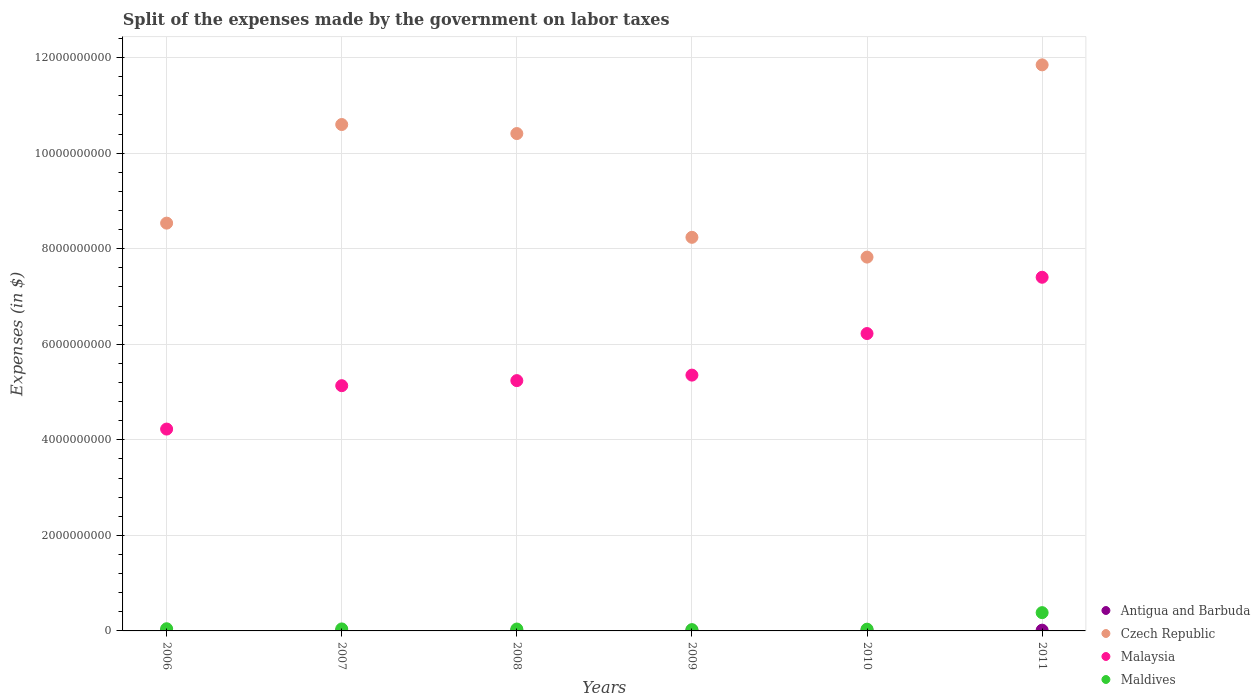How many different coloured dotlines are there?
Make the answer very short. 4. Is the number of dotlines equal to the number of legend labels?
Provide a succinct answer. Yes. What is the expenses made by the government on labor taxes in Czech Republic in 2009?
Give a very brief answer. 8.24e+09. Across all years, what is the maximum expenses made by the government on labor taxes in Antigua and Barbuda?
Your answer should be compact. 1.77e+07. Across all years, what is the minimum expenses made by the government on labor taxes in Antigua and Barbuda?
Your response must be concise. 8.90e+06. In which year was the expenses made by the government on labor taxes in Malaysia minimum?
Keep it short and to the point. 2006. What is the total expenses made by the government on labor taxes in Czech Republic in the graph?
Provide a succinct answer. 5.75e+1. What is the difference between the expenses made by the government on labor taxes in Malaysia in 2006 and that in 2010?
Your response must be concise. -2.00e+09. What is the difference between the expenses made by the government on labor taxes in Malaysia in 2006 and the expenses made by the government on labor taxes in Czech Republic in 2011?
Your answer should be compact. -7.62e+09. What is the average expenses made by the government on labor taxes in Czech Republic per year?
Your answer should be very brief. 9.58e+09. In the year 2011, what is the difference between the expenses made by the government on labor taxes in Antigua and Barbuda and expenses made by the government on labor taxes in Czech Republic?
Give a very brief answer. -1.18e+1. In how many years, is the expenses made by the government on labor taxes in Antigua and Barbuda greater than 1600000000 $?
Provide a short and direct response. 0. What is the ratio of the expenses made by the government on labor taxes in Antigua and Barbuda in 2008 to that in 2009?
Provide a short and direct response. 0.95. What is the difference between the highest and the second highest expenses made by the government on labor taxes in Maldives?
Provide a succinct answer. 3.37e+08. What is the difference between the highest and the lowest expenses made by the government on labor taxes in Maldives?
Keep it short and to the point. 3.55e+08. Does the expenses made by the government on labor taxes in Malaysia monotonically increase over the years?
Your answer should be compact. Yes. Is the expenses made by the government on labor taxes in Maldives strictly greater than the expenses made by the government on labor taxes in Czech Republic over the years?
Your answer should be very brief. No. Is the expenses made by the government on labor taxes in Antigua and Barbuda strictly less than the expenses made by the government on labor taxes in Malaysia over the years?
Your response must be concise. Yes. How many years are there in the graph?
Provide a succinct answer. 6. How many legend labels are there?
Your answer should be compact. 4. How are the legend labels stacked?
Keep it short and to the point. Vertical. What is the title of the graph?
Give a very brief answer. Split of the expenses made by the government on labor taxes. What is the label or title of the Y-axis?
Your answer should be very brief. Expenses (in $). What is the Expenses (in $) of Antigua and Barbuda in 2006?
Keep it short and to the point. 1.13e+07. What is the Expenses (in $) in Czech Republic in 2006?
Your answer should be compact. 8.54e+09. What is the Expenses (in $) in Malaysia in 2006?
Provide a succinct answer. 4.23e+09. What is the Expenses (in $) of Maldives in 2006?
Give a very brief answer. 4.56e+07. What is the Expenses (in $) of Antigua and Barbuda in 2007?
Provide a succinct answer. 8.90e+06. What is the Expenses (in $) of Czech Republic in 2007?
Your answer should be compact. 1.06e+1. What is the Expenses (in $) in Malaysia in 2007?
Make the answer very short. 5.13e+09. What is the Expenses (in $) in Maldives in 2007?
Ensure brevity in your answer.  4.18e+07. What is the Expenses (in $) of Antigua and Barbuda in 2008?
Keep it short and to the point. 1.41e+07. What is the Expenses (in $) in Czech Republic in 2008?
Ensure brevity in your answer.  1.04e+1. What is the Expenses (in $) in Malaysia in 2008?
Provide a succinct answer. 5.24e+09. What is the Expenses (in $) in Maldives in 2008?
Your response must be concise. 3.97e+07. What is the Expenses (in $) of Antigua and Barbuda in 2009?
Provide a short and direct response. 1.49e+07. What is the Expenses (in $) of Czech Republic in 2009?
Your answer should be compact. 8.24e+09. What is the Expenses (in $) in Malaysia in 2009?
Keep it short and to the point. 5.35e+09. What is the Expenses (in $) in Maldives in 2009?
Ensure brevity in your answer.  2.71e+07. What is the Expenses (in $) in Antigua and Barbuda in 2010?
Your answer should be compact. 1.77e+07. What is the Expenses (in $) in Czech Republic in 2010?
Your answer should be compact. 7.82e+09. What is the Expenses (in $) in Malaysia in 2010?
Provide a succinct answer. 6.22e+09. What is the Expenses (in $) in Maldives in 2010?
Offer a very short reply. 3.69e+07. What is the Expenses (in $) of Antigua and Barbuda in 2011?
Provide a succinct answer. 1.60e+07. What is the Expenses (in $) in Czech Republic in 2011?
Make the answer very short. 1.18e+1. What is the Expenses (in $) in Malaysia in 2011?
Make the answer very short. 7.40e+09. What is the Expenses (in $) of Maldives in 2011?
Offer a terse response. 3.83e+08. Across all years, what is the maximum Expenses (in $) in Antigua and Barbuda?
Ensure brevity in your answer.  1.77e+07. Across all years, what is the maximum Expenses (in $) of Czech Republic?
Provide a succinct answer. 1.18e+1. Across all years, what is the maximum Expenses (in $) in Malaysia?
Your response must be concise. 7.40e+09. Across all years, what is the maximum Expenses (in $) of Maldives?
Offer a very short reply. 3.83e+08. Across all years, what is the minimum Expenses (in $) in Antigua and Barbuda?
Offer a very short reply. 8.90e+06. Across all years, what is the minimum Expenses (in $) in Czech Republic?
Give a very brief answer. 7.82e+09. Across all years, what is the minimum Expenses (in $) in Malaysia?
Offer a terse response. 4.23e+09. Across all years, what is the minimum Expenses (in $) in Maldives?
Your answer should be compact. 2.71e+07. What is the total Expenses (in $) in Antigua and Barbuda in the graph?
Keep it short and to the point. 8.29e+07. What is the total Expenses (in $) in Czech Republic in the graph?
Your answer should be compact. 5.75e+1. What is the total Expenses (in $) in Malaysia in the graph?
Your answer should be compact. 3.36e+1. What is the total Expenses (in $) in Maldives in the graph?
Offer a terse response. 5.74e+08. What is the difference between the Expenses (in $) in Antigua and Barbuda in 2006 and that in 2007?
Your answer should be very brief. 2.40e+06. What is the difference between the Expenses (in $) in Czech Republic in 2006 and that in 2007?
Offer a very short reply. -2.06e+09. What is the difference between the Expenses (in $) of Malaysia in 2006 and that in 2007?
Provide a succinct answer. -9.08e+08. What is the difference between the Expenses (in $) of Maldives in 2006 and that in 2007?
Your response must be concise. 3.80e+06. What is the difference between the Expenses (in $) of Antigua and Barbuda in 2006 and that in 2008?
Ensure brevity in your answer.  -2.80e+06. What is the difference between the Expenses (in $) in Czech Republic in 2006 and that in 2008?
Offer a terse response. -1.88e+09. What is the difference between the Expenses (in $) of Malaysia in 2006 and that in 2008?
Make the answer very short. -1.01e+09. What is the difference between the Expenses (in $) of Maldives in 2006 and that in 2008?
Keep it short and to the point. 5.90e+06. What is the difference between the Expenses (in $) in Antigua and Barbuda in 2006 and that in 2009?
Give a very brief answer. -3.60e+06. What is the difference between the Expenses (in $) in Czech Republic in 2006 and that in 2009?
Offer a terse response. 2.97e+08. What is the difference between the Expenses (in $) of Malaysia in 2006 and that in 2009?
Provide a succinct answer. -1.13e+09. What is the difference between the Expenses (in $) of Maldives in 2006 and that in 2009?
Your response must be concise. 1.85e+07. What is the difference between the Expenses (in $) in Antigua and Barbuda in 2006 and that in 2010?
Provide a succinct answer. -6.40e+06. What is the difference between the Expenses (in $) in Czech Republic in 2006 and that in 2010?
Your answer should be compact. 7.11e+08. What is the difference between the Expenses (in $) of Malaysia in 2006 and that in 2010?
Offer a very short reply. -2.00e+09. What is the difference between the Expenses (in $) of Maldives in 2006 and that in 2010?
Provide a short and direct response. 8.70e+06. What is the difference between the Expenses (in $) in Antigua and Barbuda in 2006 and that in 2011?
Ensure brevity in your answer.  -4.70e+06. What is the difference between the Expenses (in $) of Czech Republic in 2006 and that in 2011?
Offer a very short reply. -3.31e+09. What is the difference between the Expenses (in $) of Malaysia in 2006 and that in 2011?
Keep it short and to the point. -3.18e+09. What is the difference between the Expenses (in $) in Maldives in 2006 and that in 2011?
Provide a succinct answer. -3.37e+08. What is the difference between the Expenses (in $) in Antigua and Barbuda in 2007 and that in 2008?
Offer a very short reply. -5.20e+06. What is the difference between the Expenses (in $) of Czech Republic in 2007 and that in 2008?
Keep it short and to the point. 1.89e+08. What is the difference between the Expenses (in $) of Malaysia in 2007 and that in 2008?
Ensure brevity in your answer.  -1.06e+08. What is the difference between the Expenses (in $) in Maldives in 2007 and that in 2008?
Offer a very short reply. 2.10e+06. What is the difference between the Expenses (in $) in Antigua and Barbuda in 2007 and that in 2009?
Give a very brief answer. -6.00e+06. What is the difference between the Expenses (in $) in Czech Republic in 2007 and that in 2009?
Keep it short and to the point. 2.36e+09. What is the difference between the Expenses (in $) of Malaysia in 2007 and that in 2009?
Offer a terse response. -2.21e+08. What is the difference between the Expenses (in $) in Maldives in 2007 and that in 2009?
Provide a short and direct response. 1.47e+07. What is the difference between the Expenses (in $) of Antigua and Barbuda in 2007 and that in 2010?
Offer a very short reply. -8.80e+06. What is the difference between the Expenses (in $) of Czech Republic in 2007 and that in 2010?
Offer a very short reply. 2.78e+09. What is the difference between the Expenses (in $) in Malaysia in 2007 and that in 2010?
Your response must be concise. -1.09e+09. What is the difference between the Expenses (in $) in Maldives in 2007 and that in 2010?
Offer a terse response. 4.90e+06. What is the difference between the Expenses (in $) in Antigua and Barbuda in 2007 and that in 2011?
Keep it short and to the point. -7.10e+06. What is the difference between the Expenses (in $) in Czech Republic in 2007 and that in 2011?
Ensure brevity in your answer.  -1.25e+09. What is the difference between the Expenses (in $) of Malaysia in 2007 and that in 2011?
Provide a succinct answer. -2.27e+09. What is the difference between the Expenses (in $) in Maldives in 2007 and that in 2011?
Ensure brevity in your answer.  -3.41e+08. What is the difference between the Expenses (in $) of Antigua and Barbuda in 2008 and that in 2009?
Make the answer very short. -8.00e+05. What is the difference between the Expenses (in $) in Czech Republic in 2008 and that in 2009?
Your response must be concise. 2.17e+09. What is the difference between the Expenses (in $) in Malaysia in 2008 and that in 2009?
Give a very brief answer. -1.15e+08. What is the difference between the Expenses (in $) of Maldives in 2008 and that in 2009?
Your response must be concise. 1.26e+07. What is the difference between the Expenses (in $) in Antigua and Barbuda in 2008 and that in 2010?
Offer a very short reply. -3.60e+06. What is the difference between the Expenses (in $) in Czech Republic in 2008 and that in 2010?
Your answer should be compact. 2.59e+09. What is the difference between the Expenses (in $) of Malaysia in 2008 and that in 2010?
Give a very brief answer. -9.85e+08. What is the difference between the Expenses (in $) of Maldives in 2008 and that in 2010?
Provide a short and direct response. 2.80e+06. What is the difference between the Expenses (in $) of Antigua and Barbuda in 2008 and that in 2011?
Offer a very short reply. -1.90e+06. What is the difference between the Expenses (in $) in Czech Republic in 2008 and that in 2011?
Keep it short and to the point. -1.44e+09. What is the difference between the Expenses (in $) in Malaysia in 2008 and that in 2011?
Your response must be concise. -2.16e+09. What is the difference between the Expenses (in $) in Maldives in 2008 and that in 2011?
Provide a succinct answer. -3.43e+08. What is the difference between the Expenses (in $) of Antigua and Barbuda in 2009 and that in 2010?
Make the answer very short. -2.80e+06. What is the difference between the Expenses (in $) in Czech Republic in 2009 and that in 2010?
Provide a short and direct response. 4.14e+08. What is the difference between the Expenses (in $) of Malaysia in 2009 and that in 2010?
Ensure brevity in your answer.  -8.70e+08. What is the difference between the Expenses (in $) in Maldives in 2009 and that in 2010?
Give a very brief answer. -9.80e+06. What is the difference between the Expenses (in $) of Antigua and Barbuda in 2009 and that in 2011?
Make the answer very short. -1.10e+06. What is the difference between the Expenses (in $) of Czech Republic in 2009 and that in 2011?
Ensure brevity in your answer.  -3.61e+09. What is the difference between the Expenses (in $) in Malaysia in 2009 and that in 2011?
Your response must be concise. -2.05e+09. What is the difference between the Expenses (in $) in Maldives in 2009 and that in 2011?
Your answer should be compact. -3.55e+08. What is the difference between the Expenses (in $) of Antigua and Barbuda in 2010 and that in 2011?
Make the answer very short. 1.70e+06. What is the difference between the Expenses (in $) in Czech Republic in 2010 and that in 2011?
Offer a very short reply. -4.02e+09. What is the difference between the Expenses (in $) of Malaysia in 2010 and that in 2011?
Provide a short and direct response. -1.18e+09. What is the difference between the Expenses (in $) in Maldives in 2010 and that in 2011?
Keep it short and to the point. -3.46e+08. What is the difference between the Expenses (in $) of Antigua and Barbuda in 2006 and the Expenses (in $) of Czech Republic in 2007?
Offer a terse response. -1.06e+1. What is the difference between the Expenses (in $) in Antigua and Barbuda in 2006 and the Expenses (in $) in Malaysia in 2007?
Make the answer very short. -5.12e+09. What is the difference between the Expenses (in $) of Antigua and Barbuda in 2006 and the Expenses (in $) of Maldives in 2007?
Provide a short and direct response. -3.05e+07. What is the difference between the Expenses (in $) of Czech Republic in 2006 and the Expenses (in $) of Malaysia in 2007?
Provide a succinct answer. 3.40e+09. What is the difference between the Expenses (in $) in Czech Republic in 2006 and the Expenses (in $) in Maldives in 2007?
Give a very brief answer. 8.49e+09. What is the difference between the Expenses (in $) in Malaysia in 2006 and the Expenses (in $) in Maldives in 2007?
Your answer should be compact. 4.18e+09. What is the difference between the Expenses (in $) in Antigua and Barbuda in 2006 and the Expenses (in $) in Czech Republic in 2008?
Make the answer very short. -1.04e+1. What is the difference between the Expenses (in $) of Antigua and Barbuda in 2006 and the Expenses (in $) of Malaysia in 2008?
Offer a terse response. -5.23e+09. What is the difference between the Expenses (in $) in Antigua and Barbuda in 2006 and the Expenses (in $) in Maldives in 2008?
Keep it short and to the point. -2.84e+07. What is the difference between the Expenses (in $) of Czech Republic in 2006 and the Expenses (in $) of Malaysia in 2008?
Keep it short and to the point. 3.30e+09. What is the difference between the Expenses (in $) of Czech Republic in 2006 and the Expenses (in $) of Maldives in 2008?
Offer a terse response. 8.50e+09. What is the difference between the Expenses (in $) of Malaysia in 2006 and the Expenses (in $) of Maldives in 2008?
Ensure brevity in your answer.  4.19e+09. What is the difference between the Expenses (in $) in Antigua and Barbuda in 2006 and the Expenses (in $) in Czech Republic in 2009?
Offer a terse response. -8.23e+09. What is the difference between the Expenses (in $) of Antigua and Barbuda in 2006 and the Expenses (in $) of Malaysia in 2009?
Keep it short and to the point. -5.34e+09. What is the difference between the Expenses (in $) of Antigua and Barbuda in 2006 and the Expenses (in $) of Maldives in 2009?
Keep it short and to the point. -1.58e+07. What is the difference between the Expenses (in $) in Czech Republic in 2006 and the Expenses (in $) in Malaysia in 2009?
Make the answer very short. 3.18e+09. What is the difference between the Expenses (in $) in Czech Republic in 2006 and the Expenses (in $) in Maldives in 2009?
Your answer should be compact. 8.51e+09. What is the difference between the Expenses (in $) in Malaysia in 2006 and the Expenses (in $) in Maldives in 2009?
Your answer should be compact. 4.20e+09. What is the difference between the Expenses (in $) of Antigua and Barbuda in 2006 and the Expenses (in $) of Czech Republic in 2010?
Offer a very short reply. -7.81e+09. What is the difference between the Expenses (in $) in Antigua and Barbuda in 2006 and the Expenses (in $) in Malaysia in 2010?
Provide a short and direct response. -6.21e+09. What is the difference between the Expenses (in $) in Antigua and Barbuda in 2006 and the Expenses (in $) in Maldives in 2010?
Your response must be concise. -2.56e+07. What is the difference between the Expenses (in $) in Czech Republic in 2006 and the Expenses (in $) in Malaysia in 2010?
Give a very brief answer. 2.31e+09. What is the difference between the Expenses (in $) of Czech Republic in 2006 and the Expenses (in $) of Maldives in 2010?
Your answer should be compact. 8.50e+09. What is the difference between the Expenses (in $) in Malaysia in 2006 and the Expenses (in $) in Maldives in 2010?
Provide a succinct answer. 4.19e+09. What is the difference between the Expenses (in $) of Antigua and Barbuda in 2006 and the Expenses (in $) of Czech Republic in 2011?
Ensure brevity in your answer.  -1.18e+1. What is the difference between the Expenses (in $) of Antigua and Barbuda in 2006 and the Expenses (in $) of Malaysia in 2011?
Your answer should be compact. -7.39e+09. What is the difference between the Expenses (in $) in Antigua and Barbuda in 2006 and the Expenses (in $) in Maldives in 2011?
Give a very brief answer. -3.71e+08. What is the difference between the Expenses (in $) of Czech Republic in 2006 and the Expenses (in $) of Malaysia in 2011?
Offer a terse response. 1.13e+09. What is the difference between the Expenses (in $) in Czech Republic in 2006 and the Expenses (in $) in Maldives in 2011?
Your answer should be compact. 8.15e+09. What is the difference between the Expenses (in $) in Malaysia in 2006 and the Expenses (in $) in Maldives in 2011?
Provide a succinct answer. 3.84e+09. What is the difference between the Expenses (in $) of Antigua and Barbuda in 2007 and the Expenses (in $) of Czech Republic in 2008?
Your answer should be very brief. -1.04e+1. What is the difference between the Expenses (in $) in Antigua and Barbuda in 2007 and the Expenses (in $) in Malaysia in 2008?
Your answer should be compact. -5.23e+09. What is the difference between the Expenses (in $) in Antigua and Barbuda in 2007 and the Expenses (in $) in Maldives in 2008?
Provide a succinct answer. -3.08e+07. What is the difference between the Expenses (in $) in Czech Republic in 2007 and the Expenses (in $) in Malaysia in 2008?
Your answer should be compact. 5.36e+09. What is the difference between the Expenses (in $) of Czech Republic in 2007 and the Expenses (in $) of Maldives in 2008?
Offer a terse response. 1.06e+1. What is the difference between the Expenses (in $) of Malaysia in 2007 and the Expenses (in $) of Maldives in 2008?
Your response must be concise. 5.09e+09. What is the difference between the Expenses (in $) of Antigua and Barbuda in 2007 and the Expenses (in $) of Czech Republic in 2009?
Provide a succinct answer. -8.23e+09. What is the difference between the Expenses (in $) in Antigua and Barbuda in 2007 and the Expenses (in $) in Malaysia in 2009?
Offer a very short reply. -5.35e+09. What is the difference between the Expenses (in $) in Antigua and Barbuda in 2007 and the Expenses (in $) in Maldives in 2009?
Provide a succinct answer. -1.82e+07. What is the difference between the Expenses (in $) of Czech Republic in 2007 and the Expenses (in $) of Malaysia in 2009?
Give a very brief answer. 5.25e+09. What is the difference between the Expenses (in $) of Czech Republic in 2007 and the Expenses (in $) of Maldives in 2009?
Offer a very short reply. 1.06e+1. What is the difference between the Expenses (in $) in Malaysia in 2007 and the Expenses (in $) in Maldives in 2009?
Your response must be concise. 5.11e+09. What is the difference between the Expenses (in $) in Antigua and Barbuda in 2007 and the Expenses (in $) in Czech Republic in 2010?
Your answer should be very brief. -7.82e+09. What is the difference between the Expenses (in $) of Antigua and Barbuda in 2007 and the Expenses (in $) of Malaysia in 2010?
Provide a short and direct response. -6.22e+09. What is the difference between the Expenses (in $) in Antigua and Barbuda in 2007 and the Expenses (in $) in Maldives in 2010?
Offer a terse response. -2.80e+07. What is the difference between the Expenses (in $) in Czech Republic in 2007 and the Expenses (in $) in Malaysia in 2010?
Your answer should be very brief. 4.38e+09. What is the difference between the Expenses (in $) in Czech Republic in 2007 and the Expenses (in $) in Maldives in 2010?
Provide a succinct answer. 1.06e+1. What is the difference between the Expenses (in $) of Malaysia in 2007 and the Expenses (in $) of Maldives in 2010?
Your answer should be very brief. 5.10e+09. What is the difference between the Expenses (in $) in Antigua and Barbuda in 2007 and the Expenses (in $) in Czech Republic in 2011?
Offer a very short reply. -1.18e+1. What is the difference between the Expenses (in $) of Antigua and Barbuda in 2007 and the Expenses (in $) of Malaysia in 2011?
Provide a succinct answer. -7.39e+09. What is the difference between the Expenses (in $) of Antigua and Barbuda in 2007 and the Expenses (in $) of Maldives in 2011?
Offer a very short reply. -3.74e+08. What is the difference between the Expenses (in $) in Czech Republic in 2007 and the Expenses (in $) in Malaysia in 2011?
Give a very brief answer. 3.20e+09. What is the difference between the Expenses (in $) in Czech Republic in 2007 and the Expenses (in $) in Maldives in 2011?
Provide a succinct answer. 1.02e+1. What is the difference between the Expenses (in $) in Malaysia in 2007 and the Expenses (in $) in Maldives in 2011?
Provide a succinct answer. 4.75e+09. What is the difference between the Expenses (in $) in Antigua and Barbuda in 2008 and the Expenses (in $) in Czech Republic in 2009?
Provide a succinct answer. -8.22e+09. What is the difference between the Expenses (in $) in Antigua and Barbuda in 2008 and the Expenses (in $) in Malaysia in 2009?
Your answer should be compact. -5.34e+09. What is the difference between the Expenses (in $) of Antigua and Barbuda in 2008 and the Expenses (in $) of Maldives in 2009?
Your response must be concise. -1.30e+07. What is the difference between the Expenses (in $) in Czech Republic in 2008 and the Expenses (in $) in Malaysia in 2009?
Make the answer very short. 5.06e+09. What is the difference between the Expenses (in $) of Czech Republic in 2008 and the Expenses (in $) of Maldives in 2009?
Offer a very short reply. 1.04e+1. What is the difference between the Expenses (in $) of Malaysia in 2008 and the Expenses (in $) of Maldives in 2009?
Your answer should be very brief. 5.21e+09. What is the difference between the Expenses (in $) in Antigua and Barbuda in 2008 and the Expenses (in $) in Czech Republic in 2010?
Your answer should be very brief. -7.81e+09. What is the difference between the Expenses (in $) of Antigua and Barbuda in 2008 and the Expenses (in $) of Malaysia in 2010?
Your response must be concise. -6.21e+09. What is the difference between the Expenses (in $) in Antigua and Barbuda in 2008 and the Expenses (in $) in Maldives in 2010?
Keep it short and to the point. -2.28e+07. What is the difference between the Expenses (in $) in Czech Republic in 2008 and the Expenses (in $) in Malaysia in 2010?
Make the answer very short. 4.19e+09. What is the difference between the Expenses (in $) in Czech Republic in 2008 and the Expenses (in $) in Maldives in 2010?
Keep it short and to the point. 1.04e+1. What is the difference between the Expenses (in $) in Malaysia in 2008 and the Expenses (in $) in Maldives in 2010?
Keep it short and to the point. 5.20e+09. What is the difference between the Expenses (in $) of Antigua and Barbuda in 2008 and the Expenses (in $) of Czech Republic in 2011?
Your answer should be compact. -1.18e+1. What is the difference between the Expenses (in $) of Antigua and Barbuda in 2008 and the Expenses (in $) of Malaysia in 2011?
Make the answer very short. -7.39e+09. What is the difference between the Expenses (in $) of Antigua and Barbuda in 2008 and the Expenses (in $) of Maldives in 2011?
Give a very brief answer. -3.68e+08. What is the difference between the Expenses (in $) of Czech Republic in 2008 and the Expenses (in $) of Malaysia in 2011?
Offer a terse response. 3.01e+09. What is the difference between the Expenses (in $) in Czech Republic in 2008 and the Expenses (in $) in Maldives in 2011?
Offer a very short reply. 1.00e+1. What is the difference between the Expenses (in $) in Malaysia in 2008 and the Expenses (in $) in Maldives in 2011?
Provide a short and direct response. 4.86e+09. What is the difference between the Expenses (in $) in Antigua and Barbuda in 2009 and the Expenses (in $) in Czech Republic in 2010?
Provide a succinct answer. -7.81e+09. What is the difference between the Expenses (in $) of Antigua and Barbuda in 2009 and the Expenses (in $) of Malaysia in 2010?
Provide a short and direct response. -6.21e+09. What is the difference between the Expenses (in $) in Antigua and Barbuda in 2009 and the Expenses (in $) in Maldives in 2010?
Provide a short and direct response. -2.20e+07. What is the difference between the Expenses (in $) of Czech Republic in 2009 and the Expenses (in $) of Malaysia in 2010?
Your answer should be compact. 2.01e+09. What is the difference between the Expenses (in $) of Czech Republic in 2009 and the Expenses (in $) of Maldives in 2010?
Provide a short and direct response. 8.20e+09. What is the difference between the Expenses (in $) in Malaysia in 2009 and the Expenses (in $) in Maldives in 2010?
Make the answer very short. 5.32e+09. What is the difference between the Expenses (in $) of Antigua and Barbuda in 2009 and the Expenses (in $) of Czech Republic in 2011?
Keep it short and to the point. -1.18e+1. What is the difference between the Expenses (in $) of Antigua and Barbuda in 2009 and the Expenses (in $) of Malaysia in 2011?
Offer a very short reply. -7.39e+09. What is the difference between the Expenses (in $) in Antigua and Barbuda in 2009 and the Expenses (in $) in Maldives in 2011?
Ensure brevity in your answer.  -3.68e+08. What is the difference between the Expenses (in $) in Czech Republic in 2009 and the Expenses (in $) in Malaysia in 2011?
Provide a short and direct response. 8.36e+08. What is the difference between the Expenses (in $) of Czech Republic in 2009 and the Expenses (in $) of Maldives in 2011?
Your answer should be very brief. 7.86e+09. What is the difference between the Expenses (in $) of Malaysia in 2009 and the Expenses (in $) of Maldives in 2011?
Ensure brevity in your answer.  4.97e+09. What is the difference between the Expenses (in $) of Antigua and Barbuda in 2010 and the Expenses (in $) of Czech Republic in 2011?
Ensure brevity in your answer.  -1.18e+1. What is the difference between the Expenses (in $) in Antigua and Barbuda in 2010 and the Expenses (in $) in Malaysia in 2011?
Your answer should be very brief. -7.39e+09. What is the difference between the Expenses (in $) in Antigua and Barbuda in 2010 and the Expenses (in $) in Maldives in 2011?
Your answer should be very brief. -3.65e+08. What is the difference between the Expenses (in $) in Czech Republic in 2010 and the Expenses (in $) in Malaysia in 2011?
Make the answer very short. 4.22e+08. What is the difference between the Expenses (in $) of Czech Republic in 2010 and the Expenses (in $) of Maldives in 2011?
Provide a short and direct response. 7.44e+09. What is the difference between the Expenses (in $) in Malaysia in 2010 and the Expenses (in $) in Maldives in 2011?
Provide a succinct answer. 5.84e+09. What is the average Expenses (in $) of Antigua and Barbuda per year?
Provide a succinct answer. 1.38e+07. What is the average Expenses (in $) in Czech Republic per year?
Offer a very short reply. 9.58e+09. What is the average Expenses (in $) of Malaysia per year?
Ensure brevity in your answer.  5.60e+09. What is the average Expenses (in $) in Maldives per year?
Provide a short and direct response. 9.56e+07. In the year 2006, what is the difference between the Expenses (in $) of Antigua and Barbuda and Expenses (in $) of Czech Republic?
Give a very brief answer. -8.52e+09. In the year 2006, what is the difference between the Expenses (in $) of Antigua and Barbuda and Expenses (in $) of Malaysia?
Your answer should be compact. -4.21e+09. In the year 2006, what is the difference between the Expenses (in $) in Antigua and Barbuda and Expenses (in $) in Maldives?
Provide a short and direct response. -3.43e+07. In the year 2006, what is the difference between the Expenses (in $) in Czech Republic and Expenses (in $) in Malaysia?
Offer a very short reply. 4.31e+09. In the year 2006, what is the difference between the Expenses (in $) in Czech Republic and Expenses (in $) in Maldives?
Provide a short and direct response. 8.49e+09. In the year 2006, what is the difference between the Expenses (in $) in Malaysia and Expenses (in $) in Maldives?
Offer a terse response. 4.18e+09. In the year 2007, what is the difference between the Expenses (in $) of Antigua and Barbuda and Expenses (in $) of Czech Republic?
Provide a succinct answer. -1.06e+1. In the year 2007, what is the difference between the Expenses (in $) in Antigua and Barbuda and Expenses (in $) in Malaysia?
Offer a terse response. -5.12e+09. In the year 2007, what is the difference between the Expenses (in $) of Antigua and Barbuda and Expenses (in $) of Maldives?
Give a very brief answer. -3.29e+07. In the year 2007, what is the difference between the Expenses (in $) of Czech Republic and Expenses (in $) of Malaysia?
Provide a succinct answer. 5.47e+09. In the year 2007, what is the difference between the Expenses (in $) of Czech Republic and Expenses (in $) of Maldives?
Keep it short and to the point. 1.06e+1. In the year 2007, what is the difference between the Expenses (in $) of Malaysia and Expenses (in $) of Maldives?
Your response must be concise. 5.09e+09. In the year 2008, what is the difference between the Expenses (in $) of Antigua and Barbuda and Expenses (in $) of Czech Republic?
Your response must be concise. -1.04e+1. In the year 2008, what is the difference between the Expenses (in $) of Antigua and Barbuda and Expenses (in $) of Malaysia?
Your answer should be compact. -5.23e+09. In the year 2008, what is the difference between the Expenses (in $) of Antigua and Barbuda and Expenses (in $) of Maldives?
Your answer should be very brief. -2.56e+07. In the year 2008, what is the difference between the Expenses (in $) of Czech Republic and Expenses (in $) of Malaysia?
Ensure brevity in your answer.  5.17e+09. In the year 2008, what is the difference between the Expenses (in $) in Czech Republic and Expenses (in $) in Maldives?
Your answer should be compact. 1.04e+1. In the year 2008, what is the difference between the Expenses (in $) in Malaysia and Expenses (in $) in Maldives?
Your response must be concise. 5.20e+09. In the year 2009, what is the difference between the Expenses (in $) in Antigua and Barbuda and Expenses (in $) in Czech Republic?
Give a very brief answer. -8.22e+09. In the year 2009, what is the difference between the Expenses (in $) of Antigua and Barbuda and Expenses (in $) of Malaysia?
Make the answer very short. -5.34e+09. In the year 2009, what is the difference between the Expenses (in $) of Antigua and Barbuda and Expenses (in $) of Maldives?
Your answer should be very brief. -1.22e+07. In the year 2009, what is the difference between the Expenses (in $) in Czech Republic and Expenses (in $) in Malaysia?
Ensure brevity in your answer.  2.88e+09. In the year 2009, what is the difference between the Expenses (in $) of Czech Republic and Expenses (in $) of Maldives?
Your answer should be very brief. 8.21e+09. In the year 2009, what is the difference between the Expenses (in $) of Malaysia and Expenses (in $) of Maldives?
Provide a short and direct response. 5.33e+09. In the year 2010, what is the difference between the Expenses (in $) in Antigua and Barbuda and Expenses (in $) in Czech Republic?
Offer a terse response. -7.81e+09. In the year 2010, what is the difference between the Expenses (in $) of Antigua and Barbuda and Expenses (in $) of Malaysia?
Ensure brevity in your answer.  -6.21e+09. In the year 2010, what is the difference between the Expenses (in $) in Antigua and Barbuda and Expenses (in $) in Maldives?
Offer a terse response. -1.92e+07. In the year 2010, what is the difference between the Expenses (in $) of Czech Republic and Expenses (in $) of Malaysia?
Provide a short and direct response. 1.60e+09. In the year 2010, what is the difference between the Expenses (in $) in Czech Republic and Expenses (in $) in Maldives?
Your answer should be compact. 7.79e+09. In the year 2010, what is the difference between the Expenses (in $) of Malaysia and Expenses (in $) of Maldives?
Ensure brevity in your answer.  6.19e+09. In the year 2011, what is the difference between the Expenses (in $) in Antigua and Barbuda and Expenses (in $) in Czech Republic?
Ensure brevity in your answer.  -1.18e+1. In the year 2011, what is the difference between the Expenses (in $) of Antigua and Barbuda and Expenses (in $) of Malaysia?
Provide a succinct answer. -7.39e+09. In the year 2011, what is the difference between the Expenses (in $) of Antigua and Barbuda and Expenses (in $) of Maldives?
Make the answer very short. -3.67e+08. In the year 2011, what is the difference between the Expenses (in $) in Czech Republic and Expenses (in $) in Malaysia?
Give a very brief answer. 4.45e+09. In the year 2011, what is the difference between the Expenses (in $) in Czech Republic and Expenses (in $) in Maldives?
Offer a terse response. 1.15e+1. In the year 2011, what is the difference between the Expenses (in $) of Malaysia and Expenses (in $) of Maldives?
Make the answer very short. 7.02e+09. What is the ratio of the Expenses (in $) in Antigua and Barbuda in 2006 to that in 2007?
Provide a short and direct response. 1.27. What is the ratio of the Expenses (in $) of Czech Republic in 2006 to that in 2007?
Provide a short and direct response. 0.81. What is the ratio of the Expenses (in $) of Malaysia in 2006 to that in 2007?
Ensure brevity in your answer.  0.82. What is the ratio of the Expenses (in $) in Maldives in 2006 to that in 2007?
Your answer should be very brief. 1.09. What is the ratio of the Expenses (in $) of Antigua and Barbuda in 2006 to that in 2008?
Provide a short and direct response. 0.8. What is the ratio of the Expenses (in $) in Czech Republic in 2006 to that in 2008?
Keep it short and to the point. 0.82. What is the ratio of the Expenses (in $) in Malaysia in 2006 to that in 2008?
Your answer should be compact. 0.81. What is the ratio of the Expenses (in $) in Maldives in 2006 to that in 2008?
Give a very brief answer. 1.15. What is the ratio of the Expenses (in $) of Antigua and Barbuda in 2006 to that in 2009?
Ensure brevity in your answer.  0.76. What is the ratio of the Expenses (in $) in Czech Republic in 2006 to that in 2009?
Keep it short and to the point. 1.04. What is the ratio of the Expenses (in $) in Malaysia in 2006 to that in 2009?
Offer a very short reply. 0.79. What is the ratio of the Expenses (in $) in Maldives in 2006 to that in 2009?
Keep it short and to the point. 1.68. What is the ratio of the Expenses (in $) of Antigua and Barbuda in 2006 to that in 2010?
Make the answer very short. 0.64. What is the ratio of the Expenses (in $) in Malaysia in 2006 to that in 2010?
Your answer should be very brief. 0.68. What is the ratio of the Expenses (in $) of Maldives in 2006 to that in 2010?
Provide a short and direct response. 1.24. What is the ratio of the Expenses (in $) in Antigua and Barbuda in 2006 to that in 2011?
Your answer should be very brief. 0.71. What is the ratio of the Expenses (in $) of Czech Republic in 2006 to that in 2011?
Give a very brief answer. 0.72. What is the ratio of the Expenses (in $) in Malaysia in 2006 to that in 2011?
Your response must be concise. 0.57. What is the ratio of the Expenses (in $) in Maldives in 2006 to that in 2011?
Provide a succinct answer. 0.12. What is the ratio of the Expenses (in $) of Antigua and Barbuda in 2007 to that in 2008?
Offer a terse response. 0.63. What is the ratio of the Expenses (in $) of Czech Republic in 2007 to that in 2008?
Give a very brief answer. 1.02. What is the ratio of the Expenses (in $) in Malaysia in 2007 to that in 2008?
Your answer should be compact. 0.98. What is the ratio of the Expenses (in $) in Maldives in 2007 to that in 2008?
Make the answer very short. 1.05. What is the ratio of the Expenses (in $) of Antigua and Barbuda in 2007 to that in 2009?
Make the answer very short. 0.6. What is the ratio of the Expenses (in $) in Czech Republic in 2007 to that in 2009?
Your answer should be very brief. 1.29. What is the ratio of the Expenses (in $) of Malaysia in 2007 to that in 2009?
Your answer should be compact. 0.96. What is the ratio of the Expenses (in $) of Maldives in 2007 to that in 2009?
Offer a terse response. 1.54. What is the ratio of the Expenses (in $) of Antigua and Barbuda in 2007 to that in 2010?
Provide a succinct answer. 0.5. What is the ratio of the Expenses (in $) in Czech Republic in 2007 to that in 2010?
Provide a succinct answer. 1.35. What is the ratio of the Expenses (in $) in Malaysia in 2007 to that in 2010?
Give a very brief answer. 0.82. What is the ratio of the Expenses (in $) of Maldives in 2007 to that in 2010?
Ensure brevity in your answer.  1.13. What is the ratio of the Expenses (in $) in Antigua and Barbuda in 2007 to that in 2011?
Provide a succinct answer. 0.56. What is the ratio of the Expenses (in $) of Czech Republic in 2007 to that in 2011?
Provide a succinct answer. 0.89. What is the ratio of the Expenses (in $) in Malaysia in 2007 to that in 2011?
Your answer should be very brief. 0.69. What is the ratio of the Expenses (in $) in Maldives in 2007 to that in 2011?
Ensure brevity in your answer.  0.11. What is the ratio of the Expenses (in $) of Antigua and Barbuda in 2008 to that in 2009?
Offer a very short reply. 0.95. What is the ratio of the Expenses (in $) of Czech Republic in 2008 to that in 2009?
Make the answer very short. 1.26. What is the ratio of the Expenses (in $) in Malaysia in 2008 to that in 2009?
Your answer should be compact. 0.98. What is the ratio of the Expenses (in $) of Maldives in 2008 to that in 2009?
Your response must be concise. 1.46. What is the ratio of the Expenses (in $) in Antigua and Barbuda in 2008 to that in 2010?
Your response must be concise. 0.8. What is the ratio of the Expenses (in $) in Czech Republic in 2008 to that in 2010?
Your response must be concise. 1.33. What is the ratio of the Expenses (in $) of Malaysia in 2008 to that in 2010?
Your response must be concise. 0.84. What is the ratio of the Expenses (in $) of Maldives in 2008 to that in 2010?
Provide a short and direct response. 1.08. What is the ratio of the Expenses (in $) of Antigua and Barbuda in 2008 to that in 2011?
Keep it short and to the point. 0.88. What is the ratio of the Expenses (in $) in Czech Republic in 2008 to that in 2011?
Keep it short and to the point. 0.88. What is the ratio of the Expenses (in $) in Malaysia in 2008 to that in 2011?
Provide a succinct answer. 0.71. What is the ratio of the Expenses (in $) of Maldives in 2008 to that in 2011?
Ensure brevity in your answer.  0.1. What is the ratio of the Expenses (in $) of Antigua and Barbuda in 2009 to that in 2010?
Keep it short and to the point. 0.84. What is the ratio of the Expenses (in $) of Czech Republic in 2009 to that in 2010?
Make the answer very short. 1.05. What is the ratio of the Expenses (in $) of Malaysia in 2009 to that in 2010?
Your answer should be compact. 0.86. What is the ratio of the Expenses (in $) in Maldives in 2009 to that in 2010?
Provide a short and direct response. 0.73. What is the ratio of the Expenses (in $) of Antigua and Barbuda in 2009 to that in 2011?
Your answer should be very brief. 0.93. What is the ratio of the Expenses (in $) in Czech Republic in 2009 to that in 2011?
Give a very brief answer. 0.7. What is the ratio of the Expenses (in $) of Malaysia in 2009 to that in 2011?
Make the answer very short. 0.72. What is the ratio of the Expenses (in $) in Maldives in 2009 to that in 2011?
Offer a very short reply. 0.07. What is the ratio of the Expenses (in $) of Antigua and Barbuda in 2010 to that in 2011?
Offer a terse response. 1.11. What is the ratio of the Expenses (in $) in Czech Republic in 2010 to that in 2011?
Ensure brevity in your answer.  0.66. What is the ratio of the Expenses (in $) in Malaysia in 2010 to that in 2011?
Provide a short and direct response. 0.84. What is the ratio of the Expenses (in $) of Maldives in 2010 to that in 2011?
Your answer should be compact. 0.1. What is the difference between the highest and the second highest Expenses (in $) in Antigua and Barbuda?
Your answer should be compact. 1.70e+06. What is the difference between the highest and the second highest Expenses (in $) in Czech Republic?
Keep it short and to the point. 1.25e+09. What is the difference between the highest and the second highest Expenses (in $) in Malaysia?
Your answer should be compact. 1.18e+09. What is the difference between the highest and the second highest Expenses (in $) in Maldives?
Provide a succinct answer. 3.37e+08. What is the difference between the highest and the lowest Expenses (in $) of Antigua and Barbuda?
Offer a very short reply. 8.80e+06. What is the difference between the highest and the lowest Expenses (in $) in Czech Republic?
Keep it short and to the point. 4.02e+09. What is the difference between the highest and the lowest Expenses (in $) of Malaysia?
Offer a very short reply. 3.18e+09. What is the difference between the highest and the lowest Expenses (in $) of Maldives?
Ensure brevity in your answer.  3.55e+08. 